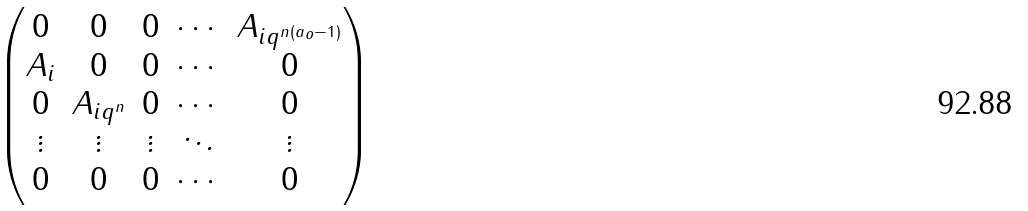<formula> <loc_0><loc_0><loc_500><loc_500>\begin{pmatrix} 0 & 0 & 0 & \cdots & A _ { i q ^ { n ( a _ { o } - 1 ) } } \\ A _ { i } & 0 & 0 & \cdots & 0 \\ 0 & A _ { i q ^ { n } } & 0 & \cdots & 0 \\ \vdots & \vdots & \vdots & \ddots & \vdots \\ 0 & 0 & 0 & \cdots & 0 \end{pmatrix}</formula> 